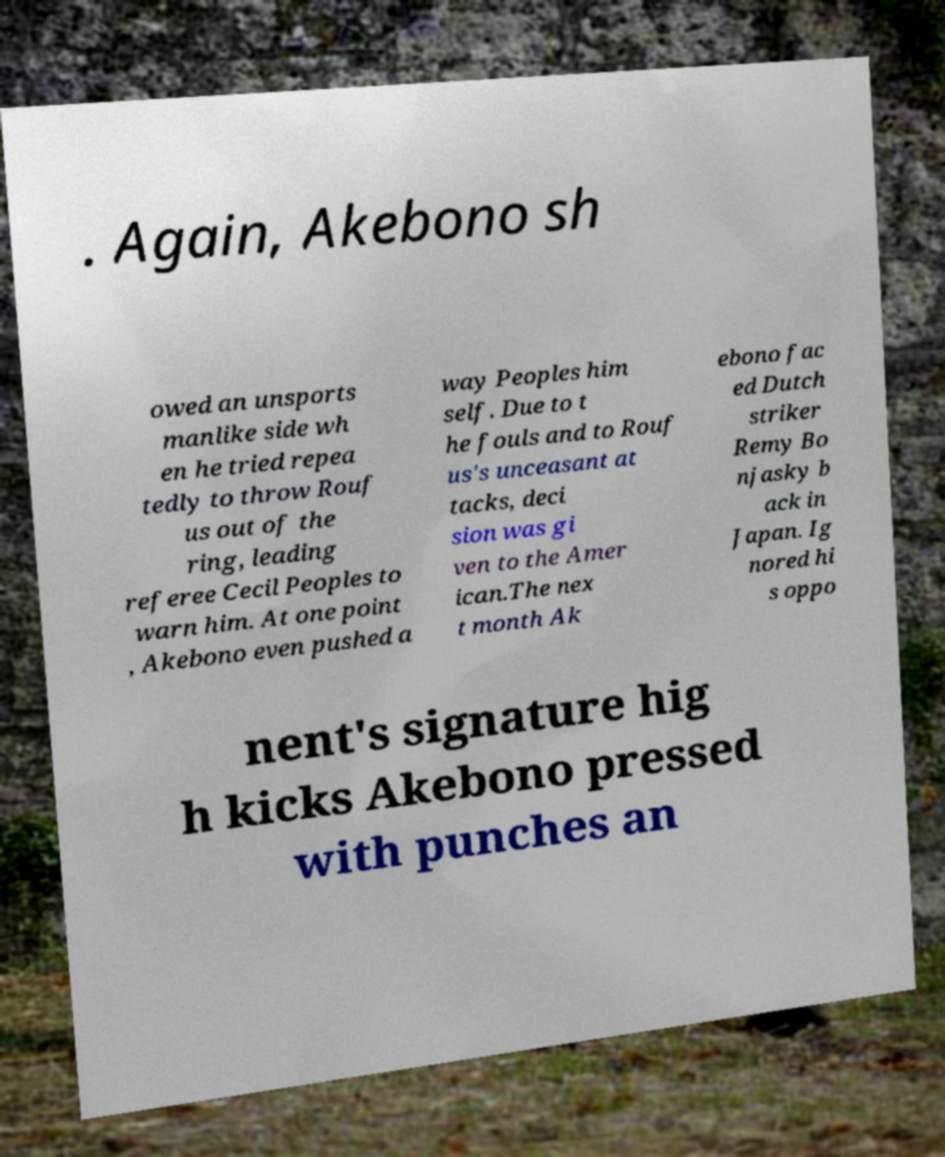Please identify and transcribe the text found in this image. . Again, Akebono sh owed an unsports manlike side wh en he tried repea tedly to throw Rouf us out of the ring, leading referee Cecil Peoples to warn him. At one point , Akebono even pushed a way Peoples him self. Due to t he fouls and to Rouf us's unceasant at tacks, deci sion was gi ven to the Amer ican.The nex t month Ak ebono fac ed Dutch striker Remy Bo njasky b ack in Japan. Ig nored hi s oppo nent's signature hig h kicks Akebono pressed with punches an 